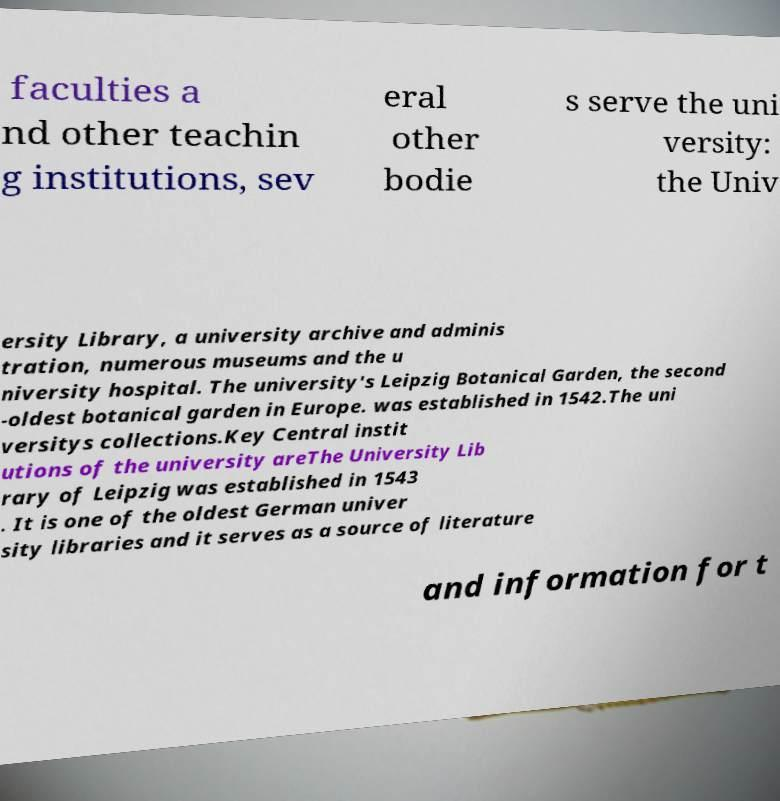Please read and relay the text visible in this image. What does it say? faculties a nd other teachin g institutions, sev eral other bodie s serve the uni versity: the Univ ersity Library, a university archive and adminis tration, numerous museums and the u niversity hospital. The university's Leipzig Botanical Garden, the second -oldest botanical garden in Europe. was established in 1542.The uni versitys collections.Key Central instit utions of the university areThe University Lib rary of Leipzig was established in 1543 . It is one of the oldest German univer sity libraries and it serves as a source of literature and information for t 